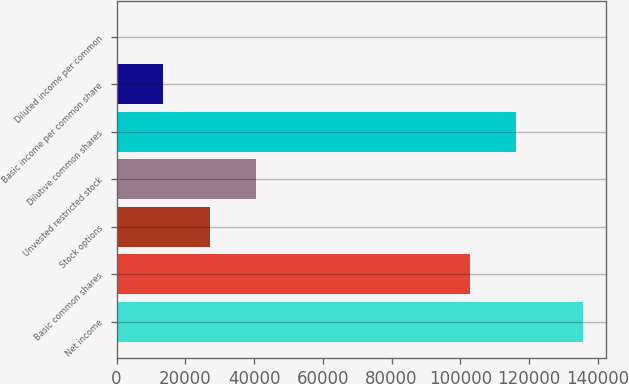Convert chart. <chart><loc_0><loc_0><loc_500><loc_500><bar_chart><fcel>Net income<fcel>Basic common shares<fcel>Stock options<fcel>Unvested restricted stock<fcel>Dilutive common shares<fcel>Basic income per common share<fcel>Diluted income per common<nl><fcel>135609<fcel>102753<fcel>27122.8<fcel>40683.6<fcel>116314<fcel>13562.1<fcel>1.31<nl></chart> 